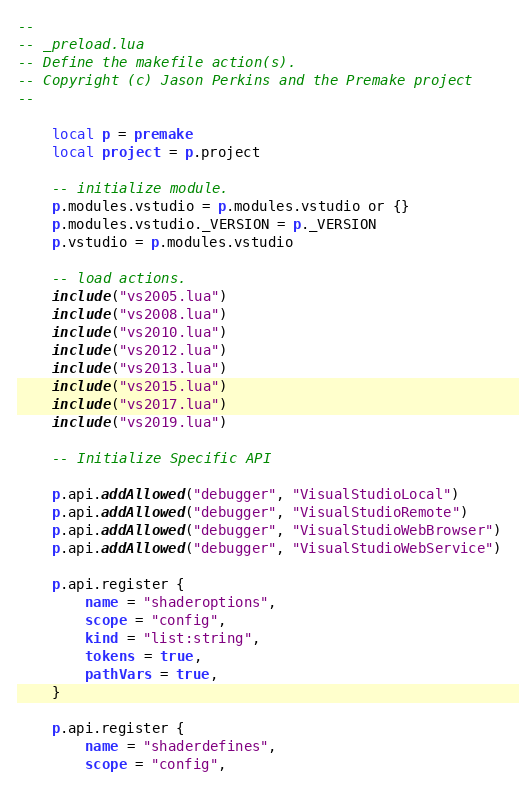<code> <loc_0><loc_0><loc_500><loc_500><_Lua_>--
-- _preload.lua
-- Define the makefile action(s).
-- Copyright (c) Jason Perkins and the Premake project
--

	local p = premake
	local project = p.project

	-- initialize module.
	p.modules.vstudio = p.modules.vstudio or {}
	p.modules.vstudio._VERSION = p._VERSION
	p.vstudio = p.modules.vstudio

	-- load actions.
	include("vs2005.lua")
	include("vs2008.lua")
	include("vs2010.lua")
	include("vs2012.lua")
	include("vs2013.lua")
	include("vs2015.lua")
	include("vs2017.lua")
	include("vs2019.lua")

	-- Initialize Specific API

	p.api.addAllowed("debugger", "VisualStudioLocal")
	p.api.addAllowed("debugger", "VisualStudioRemote")
	p.api.addAllowed("debugger", "VisualStudioWebBrowser")
	p.api.addAllowed("debugger", "VisualStudioWebService")

	p.api.register {
		name = "shaderoptions",
		scope = "config",
		kind = "list:string",
		tokens = true,
		pathVars = true,
	}

	p.api.register {
		name = "shaderdefines",
		scope = "config",</code> 